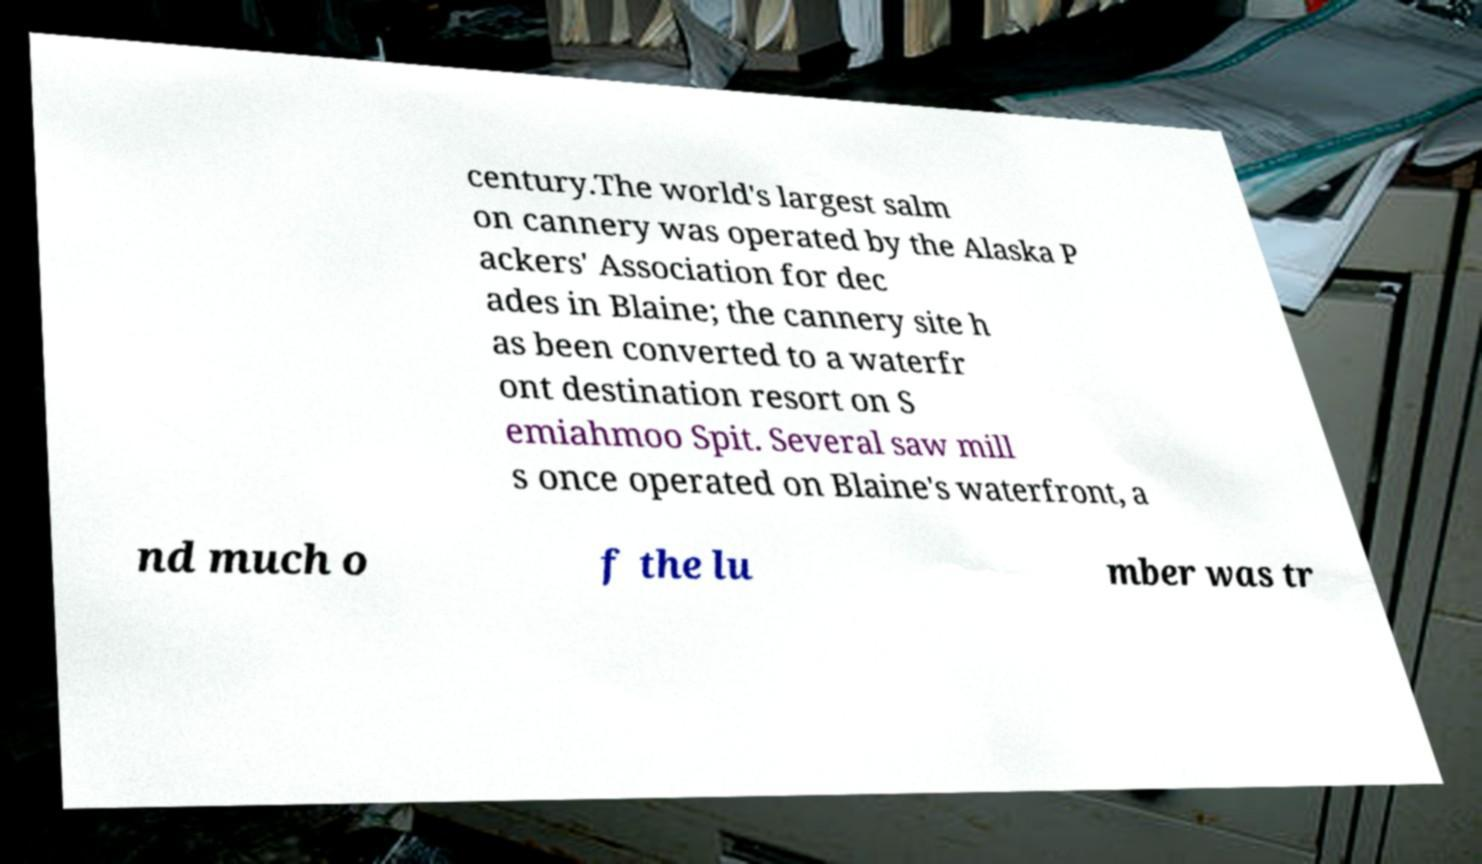For documentation purposes, I need the text within this image transcribed. Could you provide that? century.The world's largest salm on cannery was operated by the Alaska P ackers' Association for dec ades in Blaine; the cannery site h as been converted to a waterfr ont destination resort on S emiahmoo Spit. Several saw mill s once operated on Blaine's waterfront, a nd much o f the lu mber was tr 